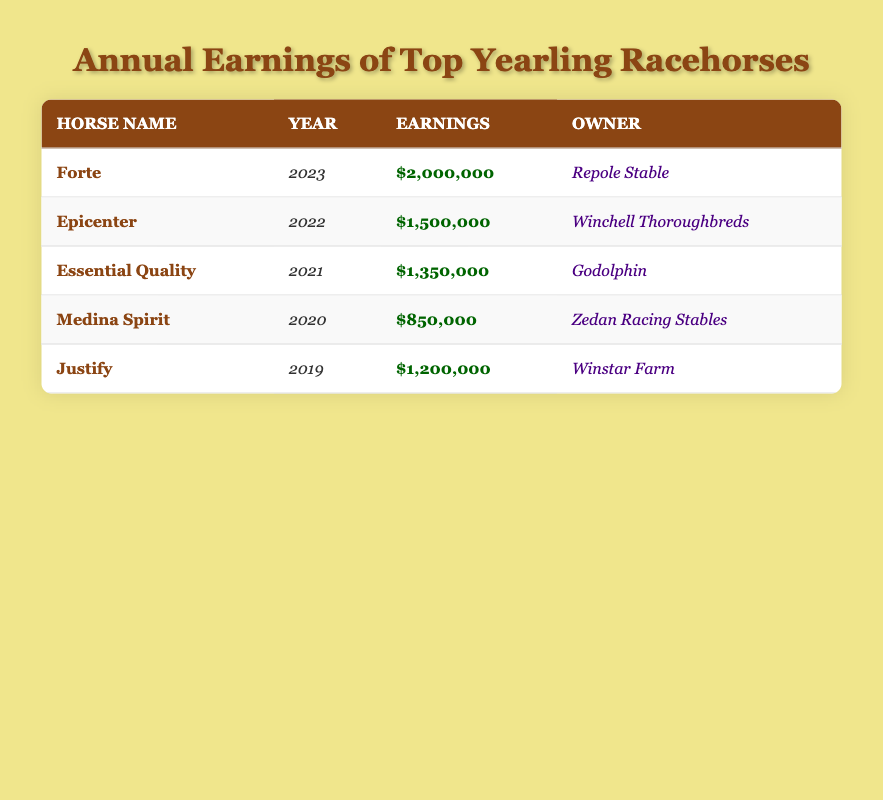What is the highest earning horse in 2023? The table shows that "Forte" has earnings of $2,000,000 in the year 2023, which is the highest for that year.
Answer: Forte Which horse had the lowest earnings? By examining the table, "Medina Spirit" shows earnings of $850,000, making it the horse with the lowest earnings among the listed horses.
Answer: Medina Spirit What is the total earnings of all the horses from 2019 to 2023? The total earnings are calculated by summing all individual earnings: $2,000,000 (Forte) + $1,500,000 (Epicenter) + $1,350,000 (Essential Quality) + $850,000 (Medina Spirit) + $1,200,000 (Justify) = $7,900,000.
Answer: $7,900,000 Did Epicenter earn more than Essential Quality? Comparing their earnings, Epicenter has $1,500,000 while Essential Quality has $1,350,000. Therefore, Epicenter did earn more.
Answer: Yes What is the average earnings of the horses for the year 2022 and 2023? The average is calculated by taking the total earnings for those years: $1,500,000 (Epicenter) + $2,000,000 (Forte) = $3,500,000. Then divide by the number of horses, which is 2: $3,500,000 / 2 = $1,750,000.
Answer: $1,750,000 Which owner had the highest-earning horse in the dataset? The highest earning horse is Forte with $2,000,000, owned by Repole Stable. Therefore, Repole Stable is the owner with the highest earning horse in the dataset.
Answer: Repole Stable What is the difference in earnings between the highest and lowest earning horses? The highest earning horse is Forte with $2,000,000, while the lowest is Medina Spirit with $850,000. The difference is calculated by subtracting the lower earning from the higher earning: $2,000,000 - $850,000 = $1,150,000.
Answer: $1,150,000 Which year had the highest combined earnings from the listed horses? From the table, 2023 has Forte's earnings alone of $2,000,000, which is the highest compared to other individual horse earnings for their respective years, indicating 2023 had the highest combined earnings.
Answer: 2023 How many horses had earnings over $1,000,000? The horses that had earnings over $1,000,000 are Forte, Epicenter, and Essential Quality. This totals to three horses in the list.
Answer: 3 What year saw the least amount of earnings for a horse? The year with the least earnings listed in the table is 2020 (Medina Spirit) with $850,000.
Answer: 2020 